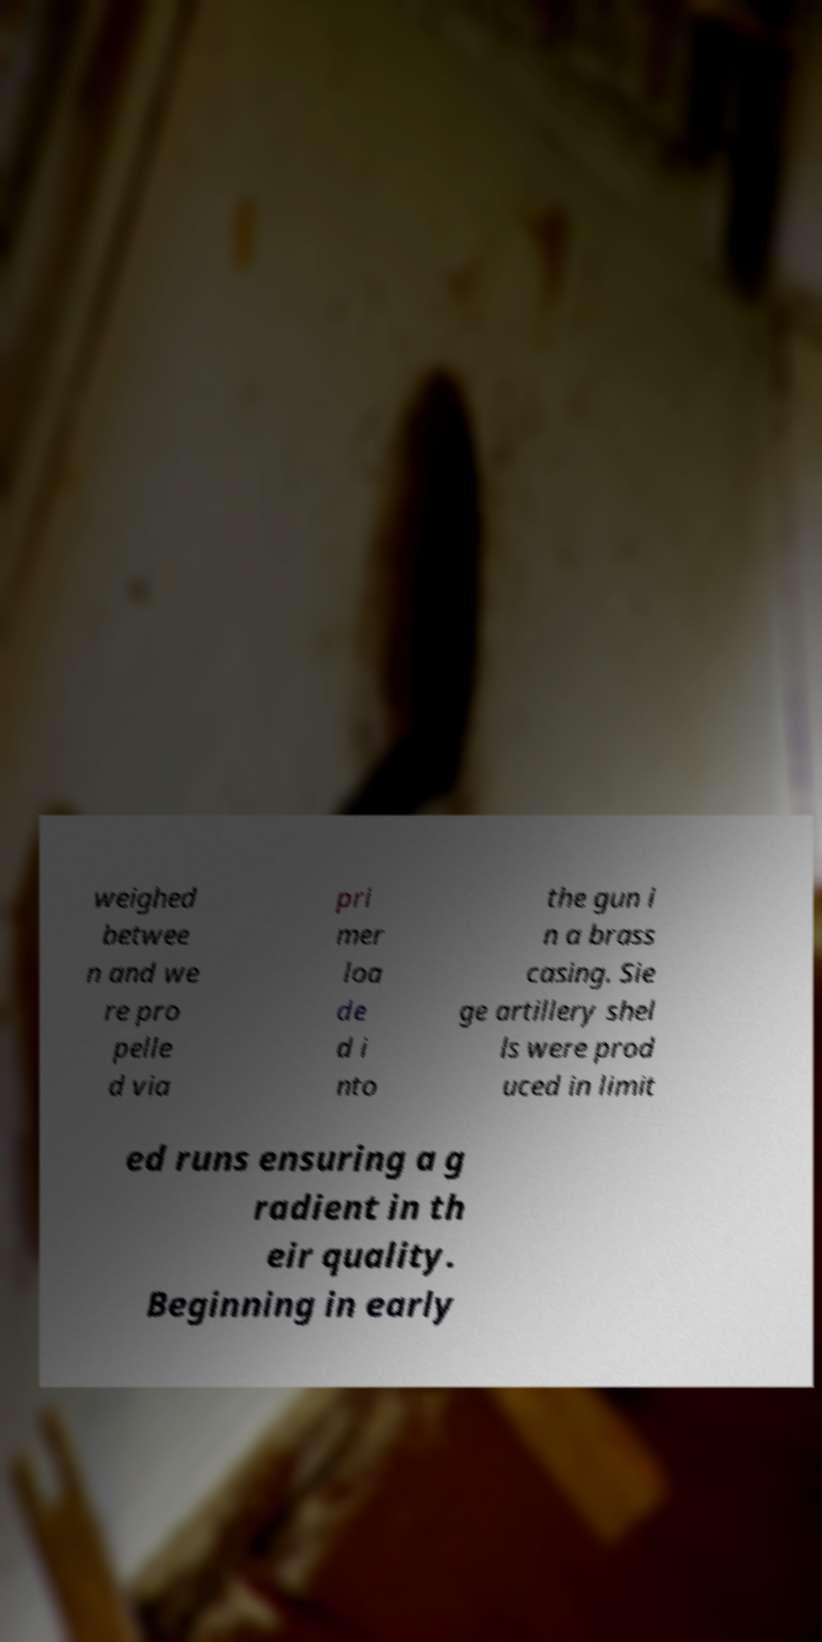For documentation purposes, I need the text within this image transcribed. Could you provide that? weighed betwee n and we re pro pelle d via pri mer loa de d i nto the gun i n a brass casing. Sie ge artillery shel ls were prod uced in limit ed runs ensuring a g radient in th eir quality. Beginning in early 